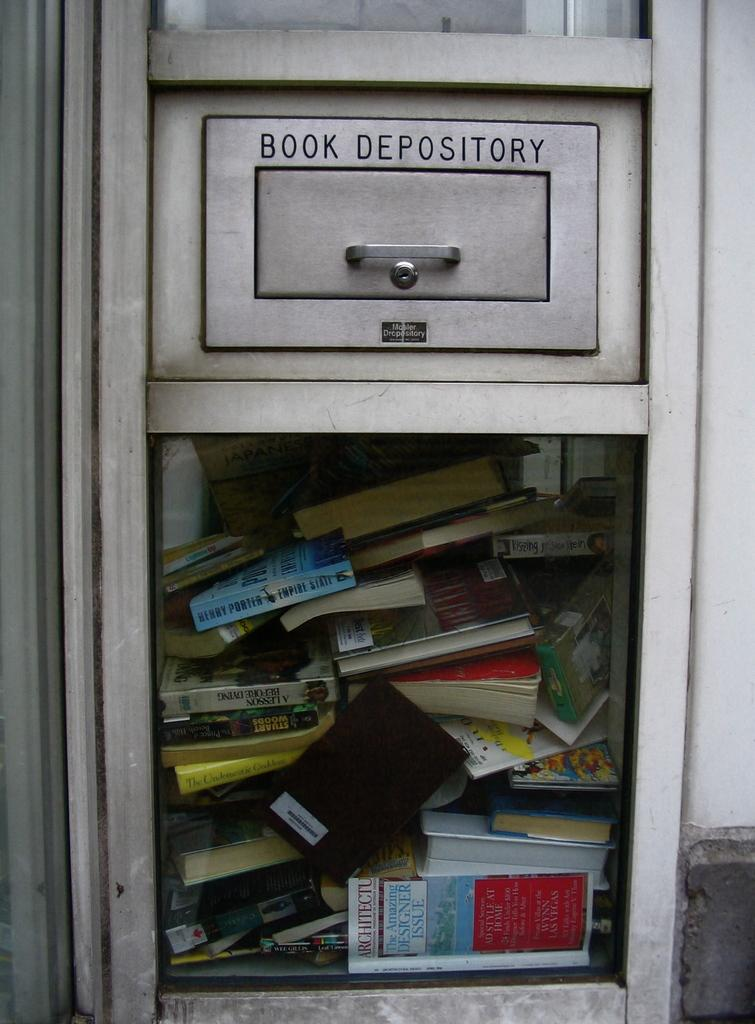Provide a one-sentence caption for the provided image. A book depository slot with a see through window the inside has books packed full. 